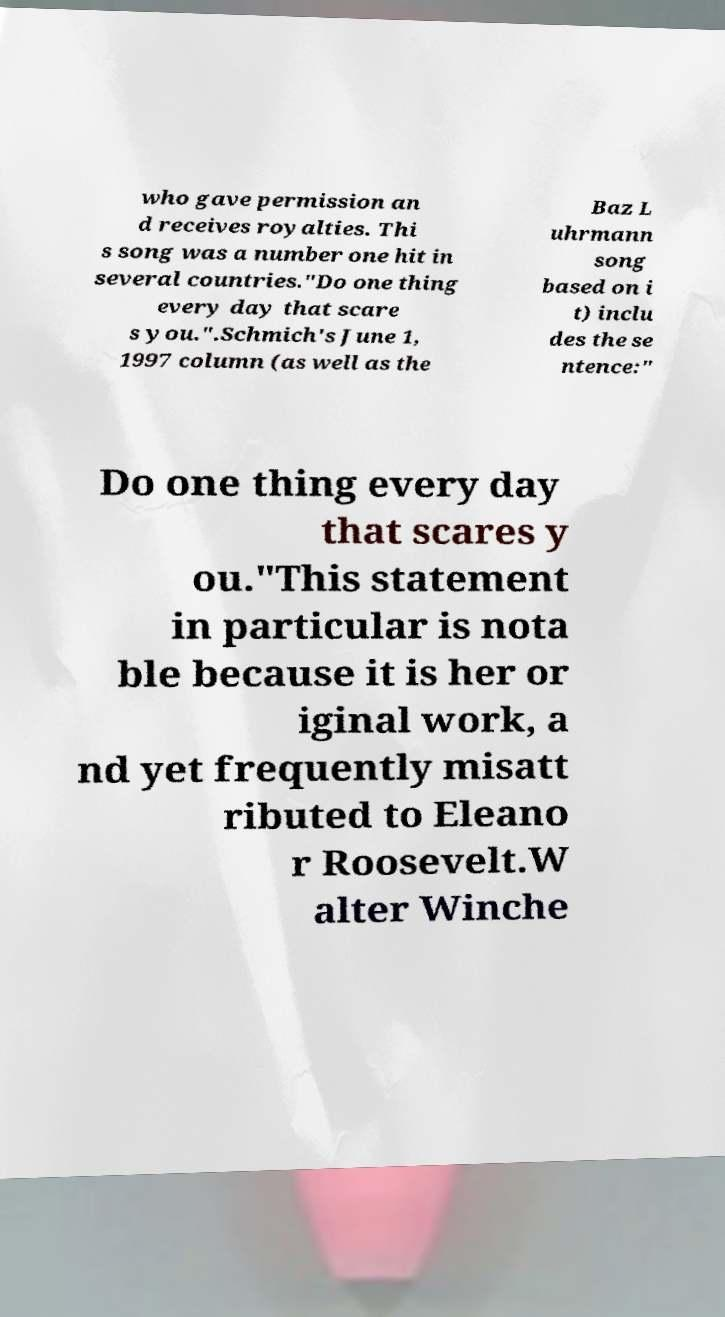Please read and relay the text visible in this image. What does it say? who gave permission an d receives royalties. Thi s song was a number one hit in several countries."Do one thing every day that scare s you.".Schmich's June 1, 1997 column (as well as the Baz L uhrmann song based on i t) inclu des the se ntence:" Do one thing every day that scares y ou."This statement in particular is nota ble because it is her or iginal work, a nd yet frequently misatt ributed to Eleano r Roosevelt.W alter Winche 